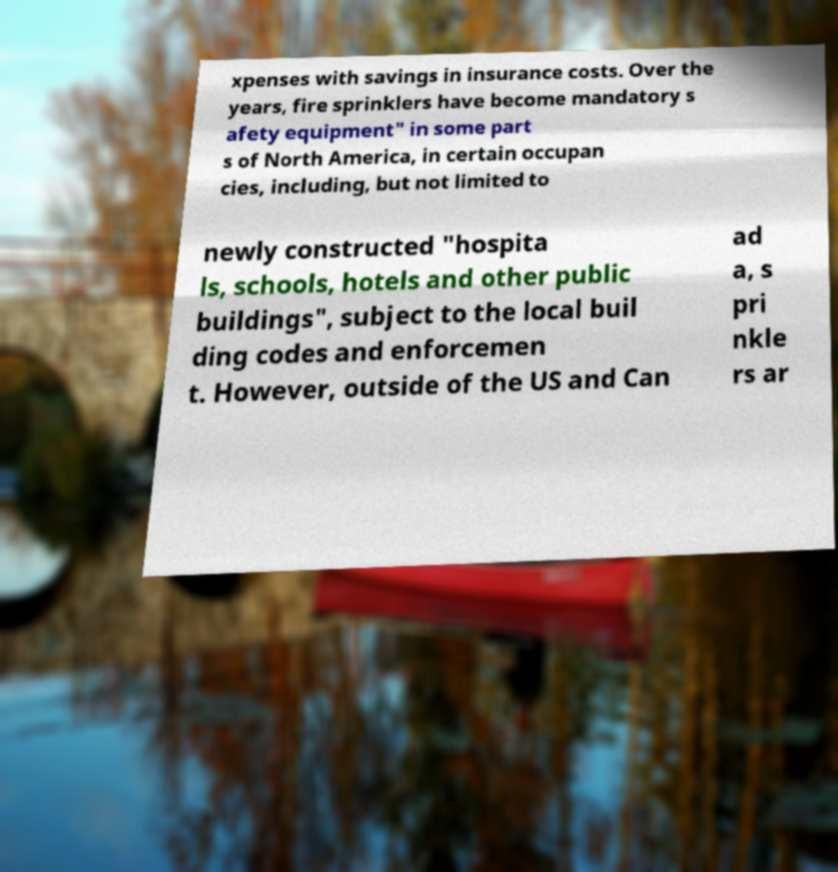Could you assist in decoding the text presented in this image and type it out clearly? xpenses with savings in insurance costs. Over the years, fire sprinklers have become mandatory s afety equipment" in some part s of North America, in certain occupan cies, including, but not limited to newly constructed "hospita ls, schools, hotels and other public buildings", subject to the local buil ding codes and enforcemen t. However, outside of the US and Can ad a, s pri nkle rs ar 